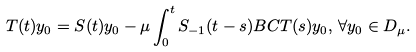<formula> <loc_0><loc_0><loc_500><loc_500>T ( t ) y _ { 0 } = S ( t ) y _ { 0 } - \mu \int _ { 0 } ^ { t } S _ { - 1 } ( t - s ) B C T ( s ) y _ { 0 } , \, \forall y _ { 0 } \in D _ { \mu } .</formula> 